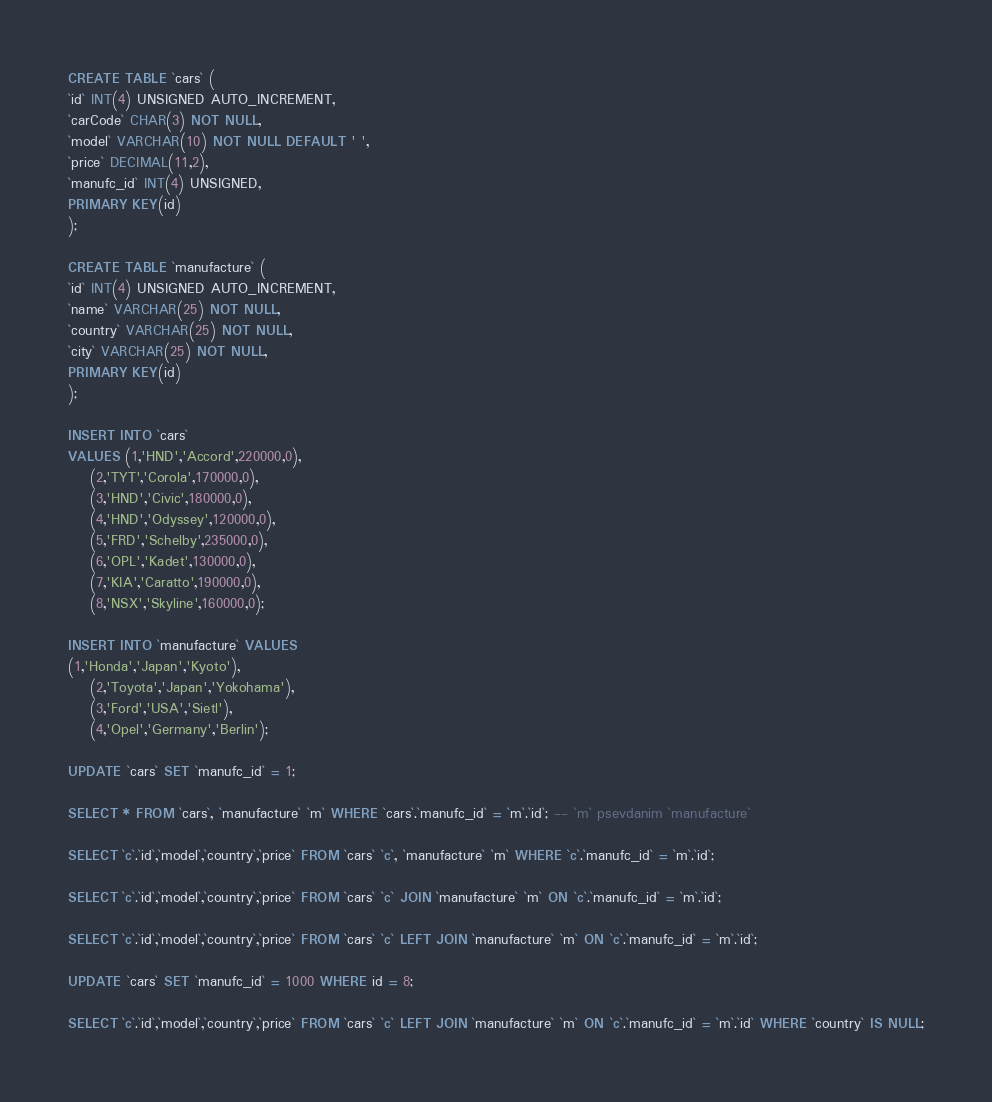Convert code to text. <code><loc_0><loc_0><loc_500><loc_500><_SQL_>CREATE TABLE `cars` (
`id` INT(4) UNSIGNED AUTO_INCREMENT,
`carCode` CHAR(3) NOT NULL,
`model` VARCHAR(10) NOT NULL DEFAULT ' ',
`price` DECIMAL(11,2),
`manufc_id` INT(4) UNSIGNED,
PRIMARY KEY(id)
);

CREATE TABLE `manufacture` (
`id` INT(4) UNSIGNED AUTO_INCREMENT,
`name` VARCHAR(25) NOT NULL,
`country` VARCHAR(25) NOT NULL,
`city` VARCHAR(25) NOT NULL,
PRIMARY KEY(id) 
);

INSERT INTO `cars`
VALUES (1,'HND','Accord',220000,0),
	(2,'TYT','Corola',170000,0),
	(3,'HND','Civic',180000,0),
	(4,'HND','Odyssey',120000,0),
	(5,'FRD','Schelby',235000,0),
	(6,'OPL','Kadet',130000,0),
	(7,'KIA','Caratto',190000,0),
	(8,'NSX','Skyline',160000,0);

INSERT INTO `manufacture` VALUES
(1,'Honda','Japan','Kyoto'),
	(2,'Toyota','Japan','Yokohama'),
	(3,'Ford','USA','Sietl'),
	(4,'Opel','Germany','Berlin');
	
UPDATE `cars` SET `manufc_id` = 1;

SELECT * FROM `cars`, `manufacture` `m` WHERE `cars`.`manufc_id` = `m`.`id`; -- `m` psevdanim `manufacture`

SELECT `c`.`id`,`model`,`country`,`price` FROM `cars` `c`, `manufacture` `m` WHERE `c`.`manufc_id` = `m`.`id`; 

SELECT `c`.`id`,`model`,`country`,`price` FROM `cars` `c` JOIN `manufacture` `m` ON `c`.`manufc_id` = `m`.`id`; 

SELECT `c`.`id`,`model`,`country`,`price` FROM `cars` `c` LEFT JOIN `manufacture` `m` ON `c`.`manufc_id` = `m`.`id`;

UPDATE `cars` SET `manufc_id` = 1000 WHERE id = 8;

SELECT `c`.`id`,`model`,`country`,`price` FROM `cars` `c` LEFT JOIN `manufacture` `m` ON `c`.`manufc_id` = `m`.`id` WHERE `country` IS NULL;
</code> 